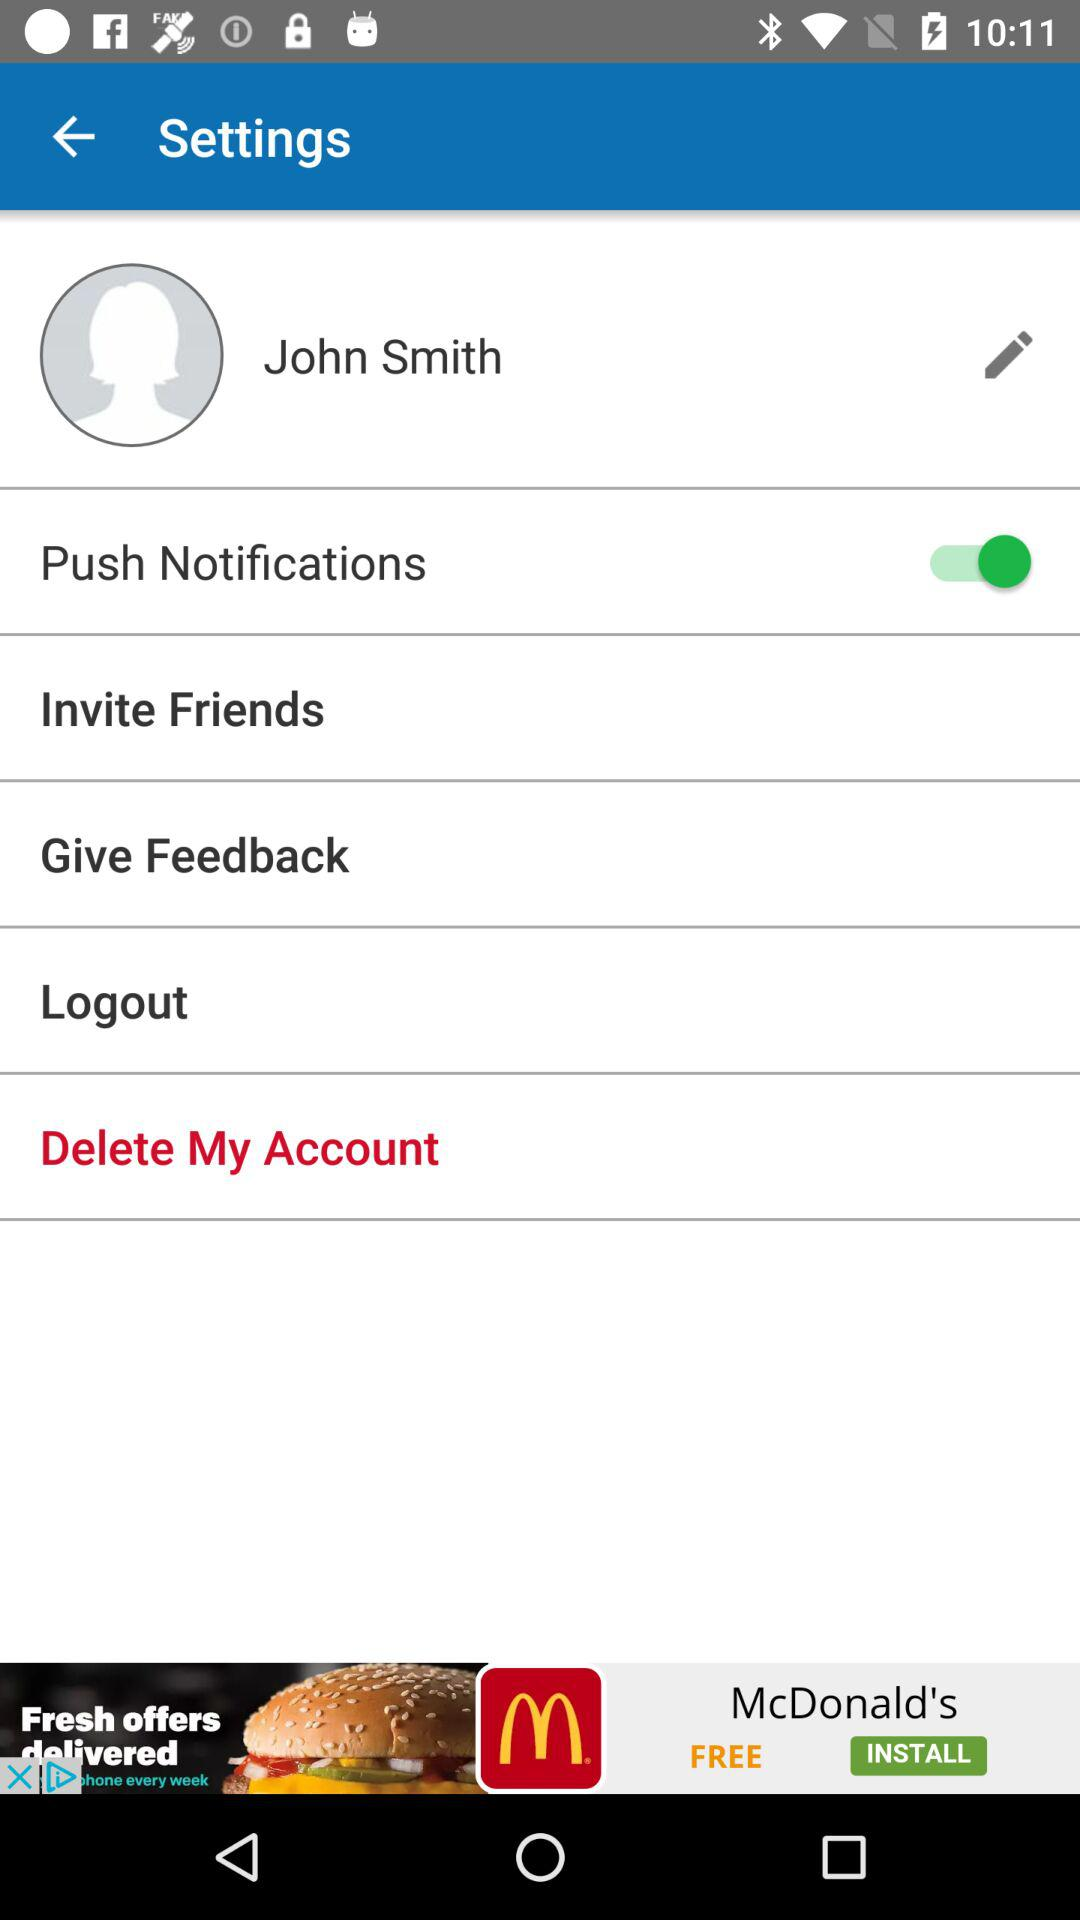Is "Push Notifications" on or off? "Push Notifications" is on. 